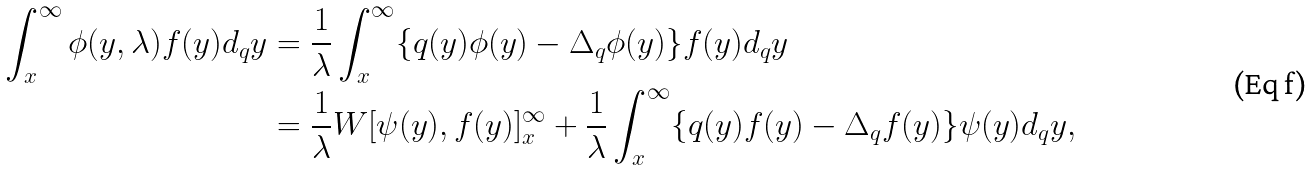<formula> <loc_0><loc_0><loc_500><loc_500>\int _ { x } ^ { \infty } \phi ( y , \lambda ) f ( y ) d _ { q } y & = \frac { 1 } { \lambda } \int _ { x } ^ { \infty } \{ q ( y ) \phi ( y ) - \Delta _ { q } \phi ( y ) \} f ( y ) d _ { q } y \\ & = \frac { 1 } { \lambda } W [ \psi ( y ) , f ( y ) ] _ { x } ^ { \infty } + \frac { 1 } { \lambda } \int _ { x } ^ { \infty } \{ q ( y ) f ( y ) - \Delta _ { q } f ( y ) \} \psi ( y ) d _ { q } y ,</formula> 